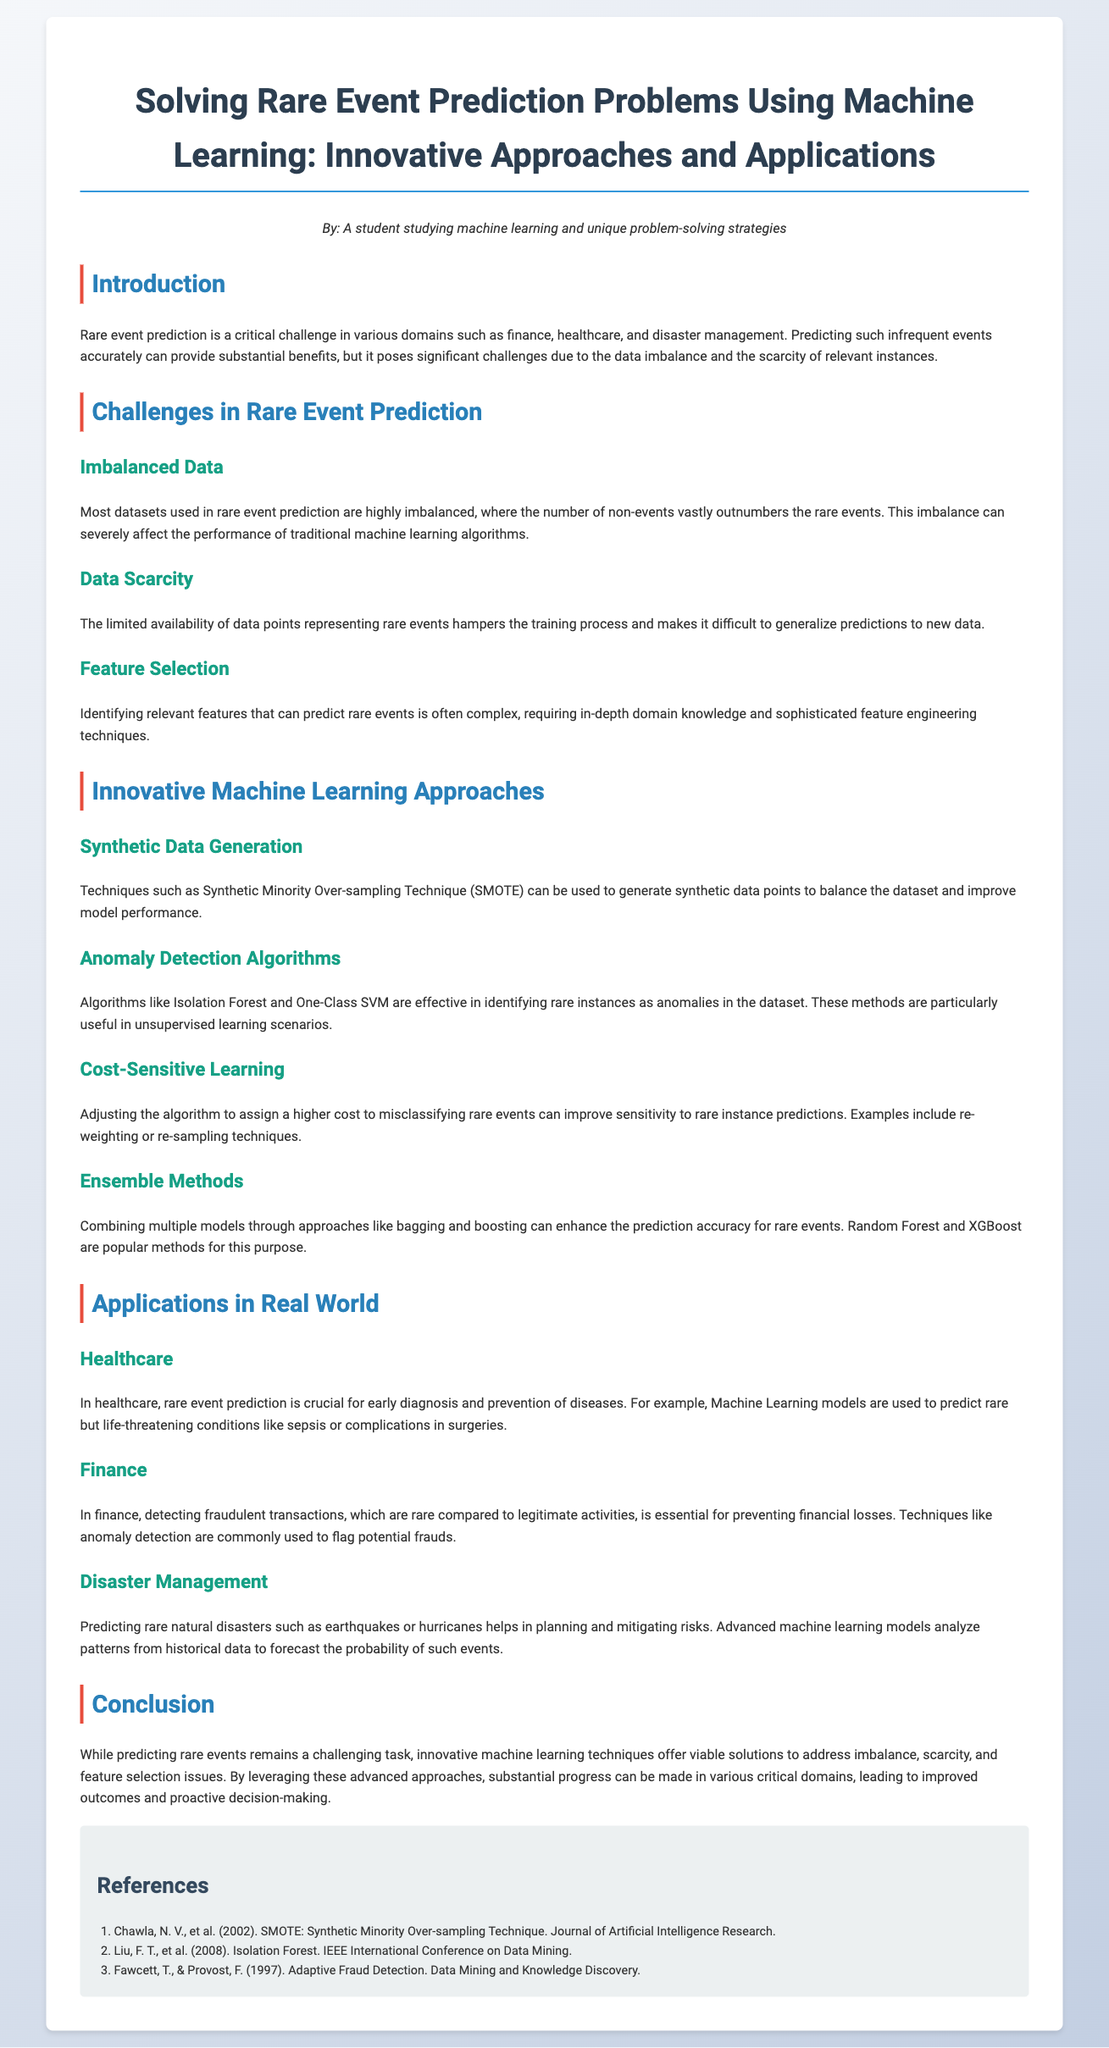What is the title of the whitepaper? The title can be found at the beginning of the document.
Answer: Solving Rare Event Prediction Problems Using Machine Learning: Innovative Approaches and Applications Who is the author of the document? The author's name is mentioned in the author section.
Answer: A student studying machine learning and unique problem-solving strategies What technique is mentioned for synthetic data generation? The document lists Synthetic Minority Over-sampling Technique as a technique used for this purpose.
Answer: SMOTE In which domain is rare event prediction crucial for early diagnosis? The document specifies that it is particularly important in the healthcare sector.
Answer: Healthcare What kind of algorithms are used to identify rare instances? The whitepaper discusses algorithms that effectively identify rare instances as anomalies.
Answer: Anomaly Detection Algorithms Which ensemble methods are popular for enhancing prediction accuracy? The document mentions Random Forest and XGBoost as examples of ensemble methods used.
Answer: Random Forest and XGBoost What is a major challenge in rare event prediction? The document highlights the imbalance of data as a significant challenge.
Answer: Imbalanced Data Which rare event is mentioned in the finance section? The document states that detecting fraudulent transactions is a rare event in finance.
Answer: Fraudulent transactions What is the application of rare event prediction in disaster management? The document outlines predicting natural disasters as an application in this sector.
Answer: Predicting natural disasters 